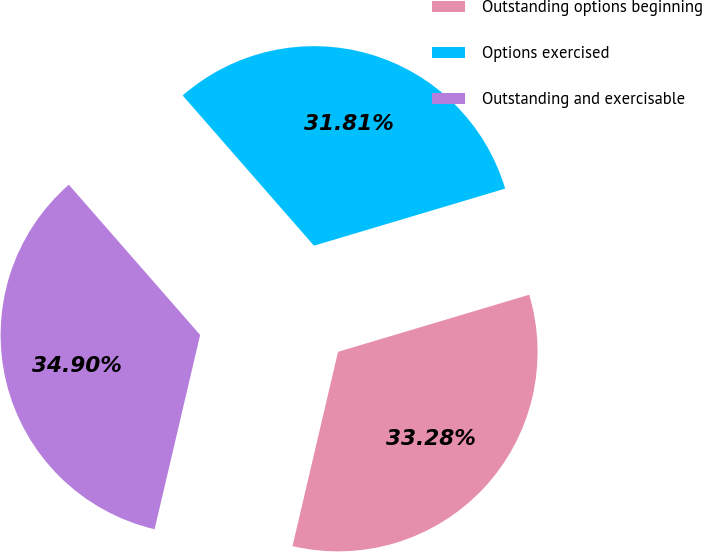Convert chart. <chart><loc_0><loc_0><loc_500><loc_500><pie_chart><fcel>Outstanding options beginning<fcel>Options exercised<fcel>Outstanding and exercisable<nl><fcel>33.28%<fcel>31.81%<fcel>34.9%<nl></chart> 